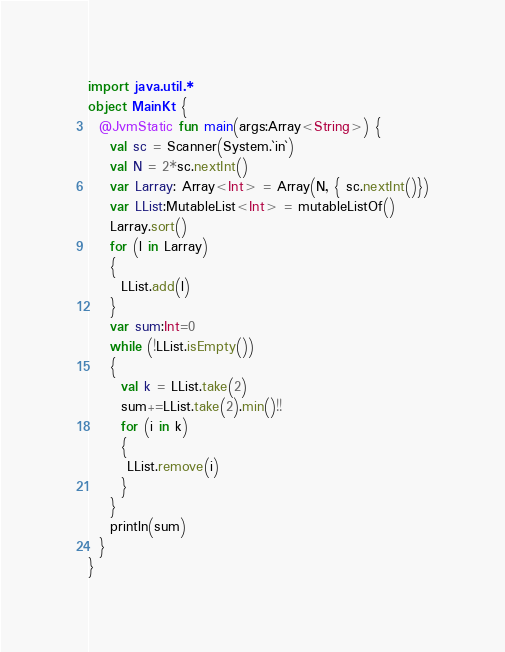Convert code to text. <code><loc_0><loc_0><loc_500><loc_500><_Kotlin_>import java.util.*
object MainKt {
  @JvmStatic fun main(args:Array<String>) {
    val sc = Scanner(System.`in`)
    val N = 2*sc.nextInt()
    var Larray: Array<Int> = Array(N, { sc.nextInt()})
    var LList:MutableList<Int> = mutableListOf()
    Larray.sort()
    for (l in Larray)
    {
      LList.add(l)
    }
    var sum:Int=0
    while (!LList.isEmpty())
    {
      val k = LList.take(2)
      sum+=LList.take(2).min()!!
      for (i in k)
      {
       LList.remove(i)
      }
    }
    println(sum)
  }
}
</code> 